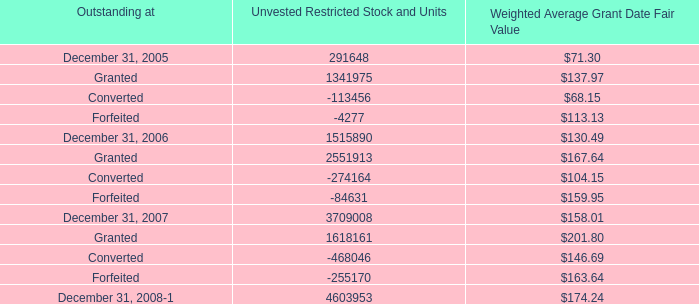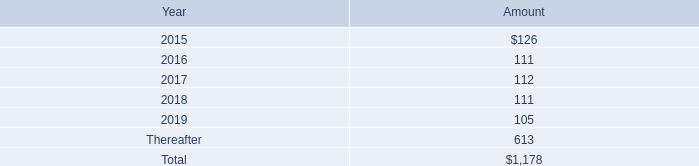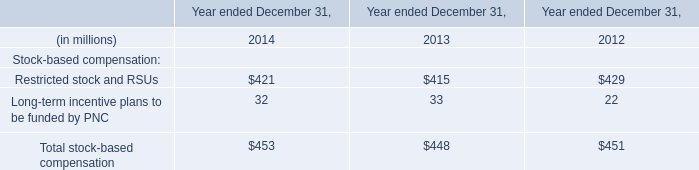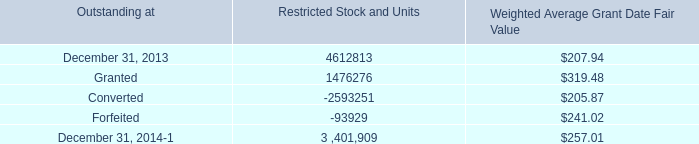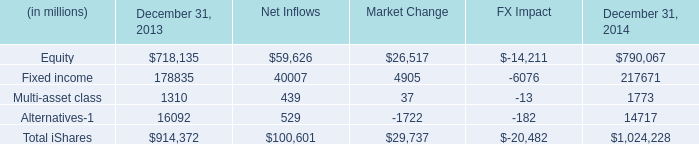What is the sum of Equity of Net Inflows, and Forfeited of Restricted Stock and Units ? 
Computations: (59626.0 + 93929.0)
Answer: 153555.0. 